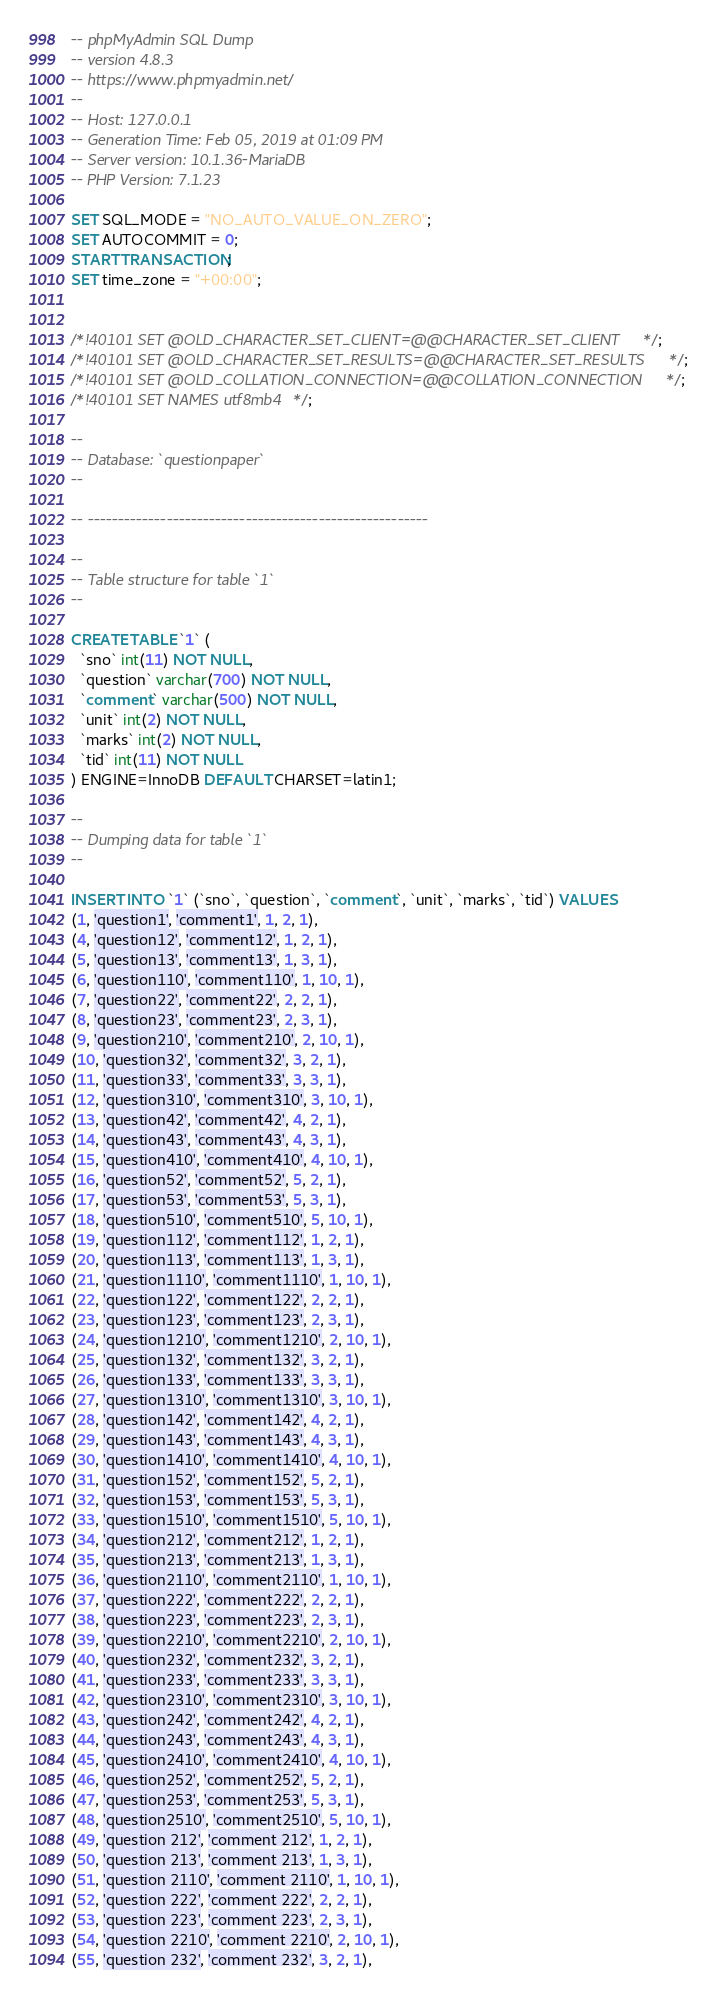<code> <loc_0><loc_0><loc_500><loc_500><_SQL_>-- phpMyAdmin SQL Dump
-- version 4.8.3
-- https://www.phpmyadmin.net/
--
-- Host: 127.0.0.1
-- Generation Time: Feb 05, 2019 at 01:09 PM
-- Server version: 10.1.36-MariaDB
-- PHP Version: 7.1.23

SET SQL_MODE = "NO_AUTO_VALUE_ON_ZERO";
SET AUTOCOMMIT = 0;
START TRANSACTION;
SET time_zone = "+00:00";


/*!40101 SET @OLD_CHARACTER_SET_CLIENT=@@CHARACTER_SET_CLIENT */;
/*!40101 SET @OLD_CHARACTER_SET_RESULTS=@@CHARACTER_SET_RESULTS */;
/*!40101 SET @OLD_COLLATION_CONNECTION=@@COLLATION_CONNECTION */;
/*!40101 SET NAMES utf8mb4 */;

--
-- Database: `questionpaper`
--

-- --------------------------------------------------------

--
-- Table structure for table `1`
--

CREATE TABLE `1` (
  `sno` int(11) NOT NULL,
  `question` varchar(700) NOT NULL,
  `comment` varchar(500) NOT NULL,
  `unit` int(2) NOT NULL,
  `marks` int(2) NOT NULL,
  `tid` int(11) NOT NULL
) ENGINE=InnoDB DEFAULT CHARSET=latin1;

--
-- Dumping data for table `1`
--

INSERT INTO `1` (`sno`, `question`, `comment`, `unit`, `marks`, `tid`) VALUES
(1, 'question1', 'comment1', 1, 2, 1),
(4, 'question12', 'comment12', 1, 2, 1),
(5, 'question13', 'comment13', 1, 3, 1),
(6, 'question110', 'comment110', 1, 10, 1),
(7, 'question22', 'comment22', 2, 2, 1),
(8, 'question23', 'comment23', 2, 3, 1),
(9, 'question210', 'comment210', 2, 10, 1),
(10, 'question32', 'comment32', 3, 2, 1),
(11, 'question33', 'comment33', 3, 3, 1),
(12, 'question310', 'comment310', 3, 10, 1),
(13, 'question42', 'comment42', 4, 2, 1),
(14, 'question43', 'comment43', 4, 3, 1),
(15, 'question410', 'comment410', 4, 10, 1),
(16, 'question52', 'comment52', 5, 2, 1),
(17, 'question53', 'comment53', 5, 3, 1),
(18, 'question510', 'comment510', 5, 10, 1),
(19, 'question112', 'comment112', 1, 2, 1),
(20, 'question113', 'comment113', 1, 3, 1),
(21, 'question1110', 'comment1110', 1, 10, 1),
(22, 'question122', 'comment122', 2, 2, 1),
(23, 'question123', 'comment123', 2, 3, 1),
(24, 'question1210', 'comment1210', 2, 10, 1),
(25, 'question132', 'comment132', 3, 2, 1),
(26, 'question133', 'comment133', 3, 3, 1),
(27, 'question1310', 'comment1310', 3, 10, 1),
(28, 'question142', 'comment142', 4, 2, 1),
(29, 'question143', 'comment143', 4, 3, 1),
(30, 'question1410', 'comment1410', 4, 10, 1),
(31, 'question152', 'comment152', 5, 2, 1),
(32, 'question153', 'comment153', 5, 3, 1),
(33, 'question1510', 'comment1510', 5, 10, 1),
(34, 'question212', 'comment212', 1, 2, 1),
(35, 'question213', 'comment213', 1, 3, 1),
(36, 'question2110', 'comment2110', 1, 10, 1),
(37, 'question222', 'comment222', 2, 2, 1),
(38, 'question223', 'comment223', 2, 3, 1),
(39, 'question2210', 'comment2210', 2, 10, 1),
(40, 'question232', 'comment232', 3, 2, 1),
(41, 'question233', 'comment233', 3, 3, 1),
(42, 'question2310', 'comment2310', 3, 10, 1),
(43, 'question242', 'comment242', 4, 2, 1),
(44, 'question243', 'comment243', 4, 3, 1),
(45, 'question2410', 'comment2410', 4, 10, 1),
(46, 'question252', 'comment252', 5, 2, 1),
(47, 'question253', 'comment253', 5, 3, 1),
(48, 'question2510', 'comment2510', 5, 10, 1),
(49, 'question 212', 'comment 212', 1, 2, 1),
(50, 'question 213', 'comment 213', 1, 3, 1),
(51, 'question 2110', 'comment 2110', 1, 10, 1),
(52, 'question 222', 'comment 222', 2, 2, 1),
(53, 'question 223', 'comment 223', 2, 3, 1),
(54, 'question 2210', 'comment 2210', 2, 10, 1),
(55, 'question 232', 'comment 232', 3, 2, 1),</code> 